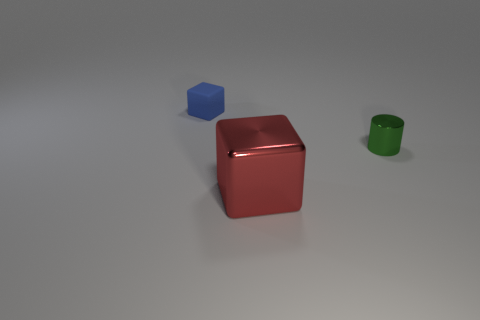Add 3 big cubes. How many objects exist? 6 Subtract all blocks. How many objects are left? 1 Add 1 large red rubber things. How many large red rubber things exist? 1 Subtract 0 yellow cylinders. How many objects are left? 3 Subtract all tiny gray shiny objects. Subtract all red metallic objects. How many objects are left? 2 Add 3 small shiny cylinders. How many small shiny cylinders are left? 4 